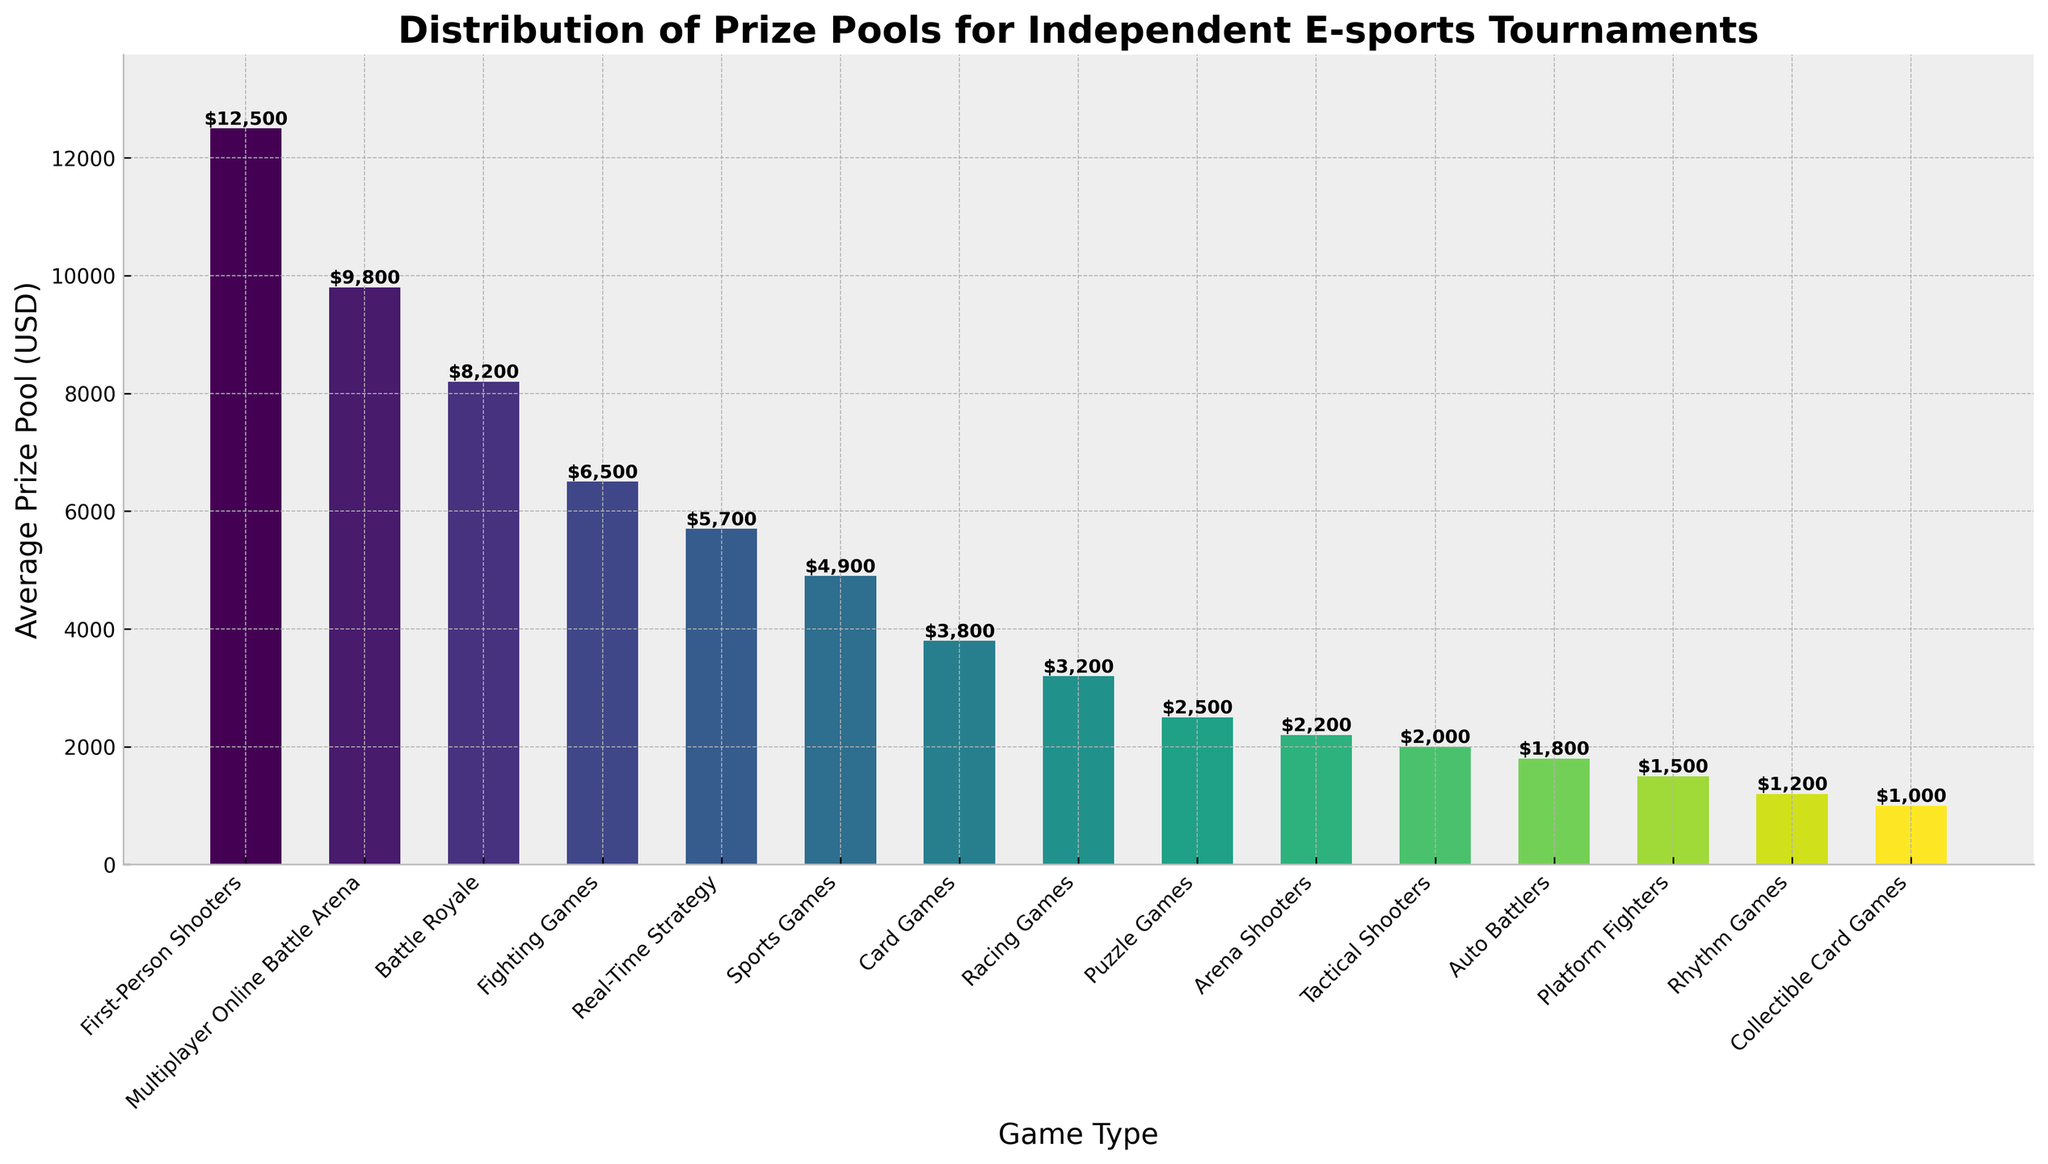What's the average prize pool difference between First-Person Shooters and Real-Time Strategy games? The prize pool for First-Person Shooters is $12,500 and for Real-Time Strategy games is $5,700. The difference is $12,500 - $5,700 = $6,800.
Answer: $6,800 Which game type has the lowest prize pool and how much is it? The game type Collectible Card Games has the lowest average prize pool, which is $1,000. This can be verified visually as it's the shortest bar in the chart.
Answer: Collectible Card Games, $1,000 How does the prize pool of Multiplayer Online Battle Arena games compare to Card Games? The prize pool for Multiplayer Online Battle Arena games is $9,800, while for Card Games it's $3,800. Therefore, the Multiplayer Online Battle Arena games have a higher prize pool.
Answer: Multiplayer Online Battle Arena games have a higher prize pool What is the total prize pool of the top three game types by average prize pool? The top three game types by average prize pool are First-Person Shooters ($12,500), Multiplayer Online Battle Arena ($9,800), and Battle Royale ($8,200). The total is: $12,500 + $9,800 + $8,200 = $30,500.
Answer: $30,500 By how much does the prize pool for Fighting Games exceed that of Tactical Shooters? The prize pool for Fighting Games is $6,500 and for Tactical Shooters is $2,000. The difference is $6,500 - $2,000 = $4,500.
Answer: $4,500 Which game type has an average prize pool closest to $7,000? The average prize pool closest to $7,000 is for Fighting Games, which is $6,500.
Answer: Fighting Games What is the combined average prize pool of Rhythm Games and Auto Battlers? The average prize pool for Rhythm Games is $1,200 and for Auto Battlers is $1,800. The combined total is $1,200 + $1,800 = $3,000.
Answer: $3,000 How many game types have an average prize pool lower than $5,000? By examining the chart, the game types with an average prize pool lower than $5,000 are: Sports Games, Card Games, Racing Games, Puzzle Games, Arena Shooters, Tactical Shooters, Auto Battlers, Platform Fighters, Rhythm Games, and Collectible Card Games. There are 10 such game types.
Answer: 10 Which has a higher prize pool: Sports Games or Racing Games, and by how much? Sports Games have an average prize pool of $4,900, while Racing Games have $3,200. The difference is $4,900 - $3,200 = $1,700.
Answer: Sports Games by $1,700 Name two game types with their prize pools at each end of the color gradient in the figure. The figure uses a color gradient where First-Person Shooters ($12,500) appear at one end and Collectible Card Games ($1,000) at the other.
Answer: First-Person Shooters ($12,500) and Collectible Card Games ($1,000) 